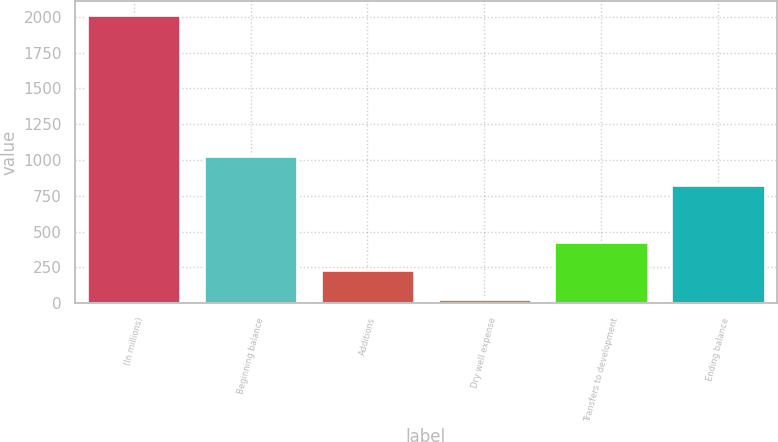Convert chart to OTSL. <chart><loc_0><loc_0><loc_500><loc_500><bar_chart><fcel>(In millions)<fcel>Beginning balance<fcel>Additions<fcel>Dry well expense<fcel>Transfers to development<fcel>Ending balance<nl><fcel>2009<fcel>1026.7<fcel>229.7<fcel>32<fcel>427.4<fcel>829<nl></chart> 